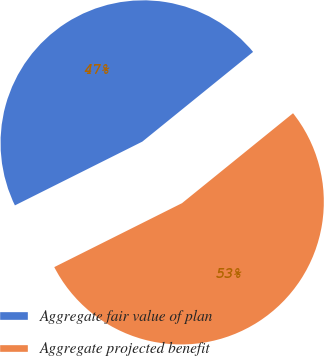<chart> <loc_0><loc_0><loc_500><loc_500><pie_chart><fcel>Aggregate fair value of plan<fcel>Aggregate projected benefit<nl><fcel>46.55%<fcel>53.45%<nl></chart> 